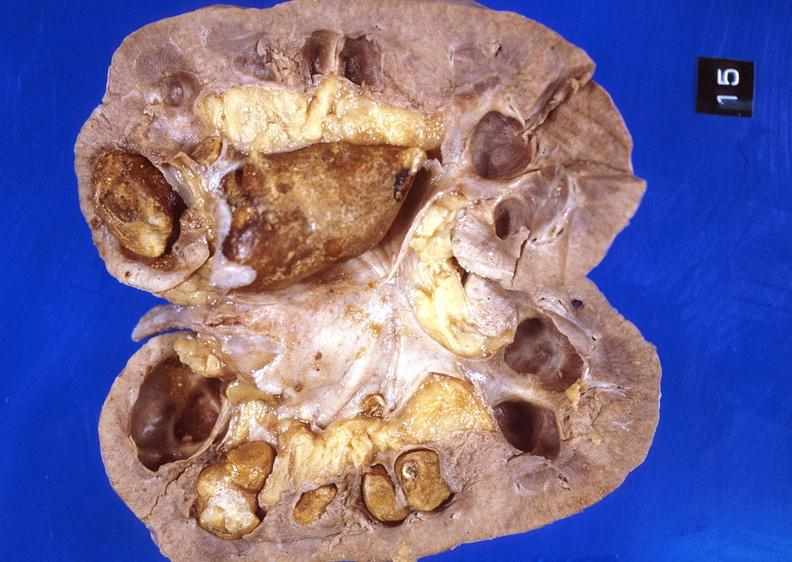does this image show kidney, staghorn calculi?
Answer the question using a single word or phrase. Yes 